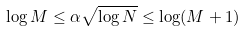<formula> <loc_0><loc_0><loc_500><loc_500>\log M \leq \alpha \sqrt { \log N } \leq \log ( M + 1 )</formula> 